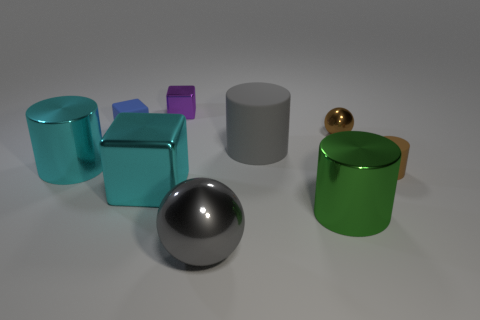Do the brown matte thing and the shiny cylinder left of the tiny purple object have the same size? The brown matte object and the shiny cylinder do not have the same size. The cylinder appears slightly taller and narrower when compared to the brown object, which is shorter and has more width. 